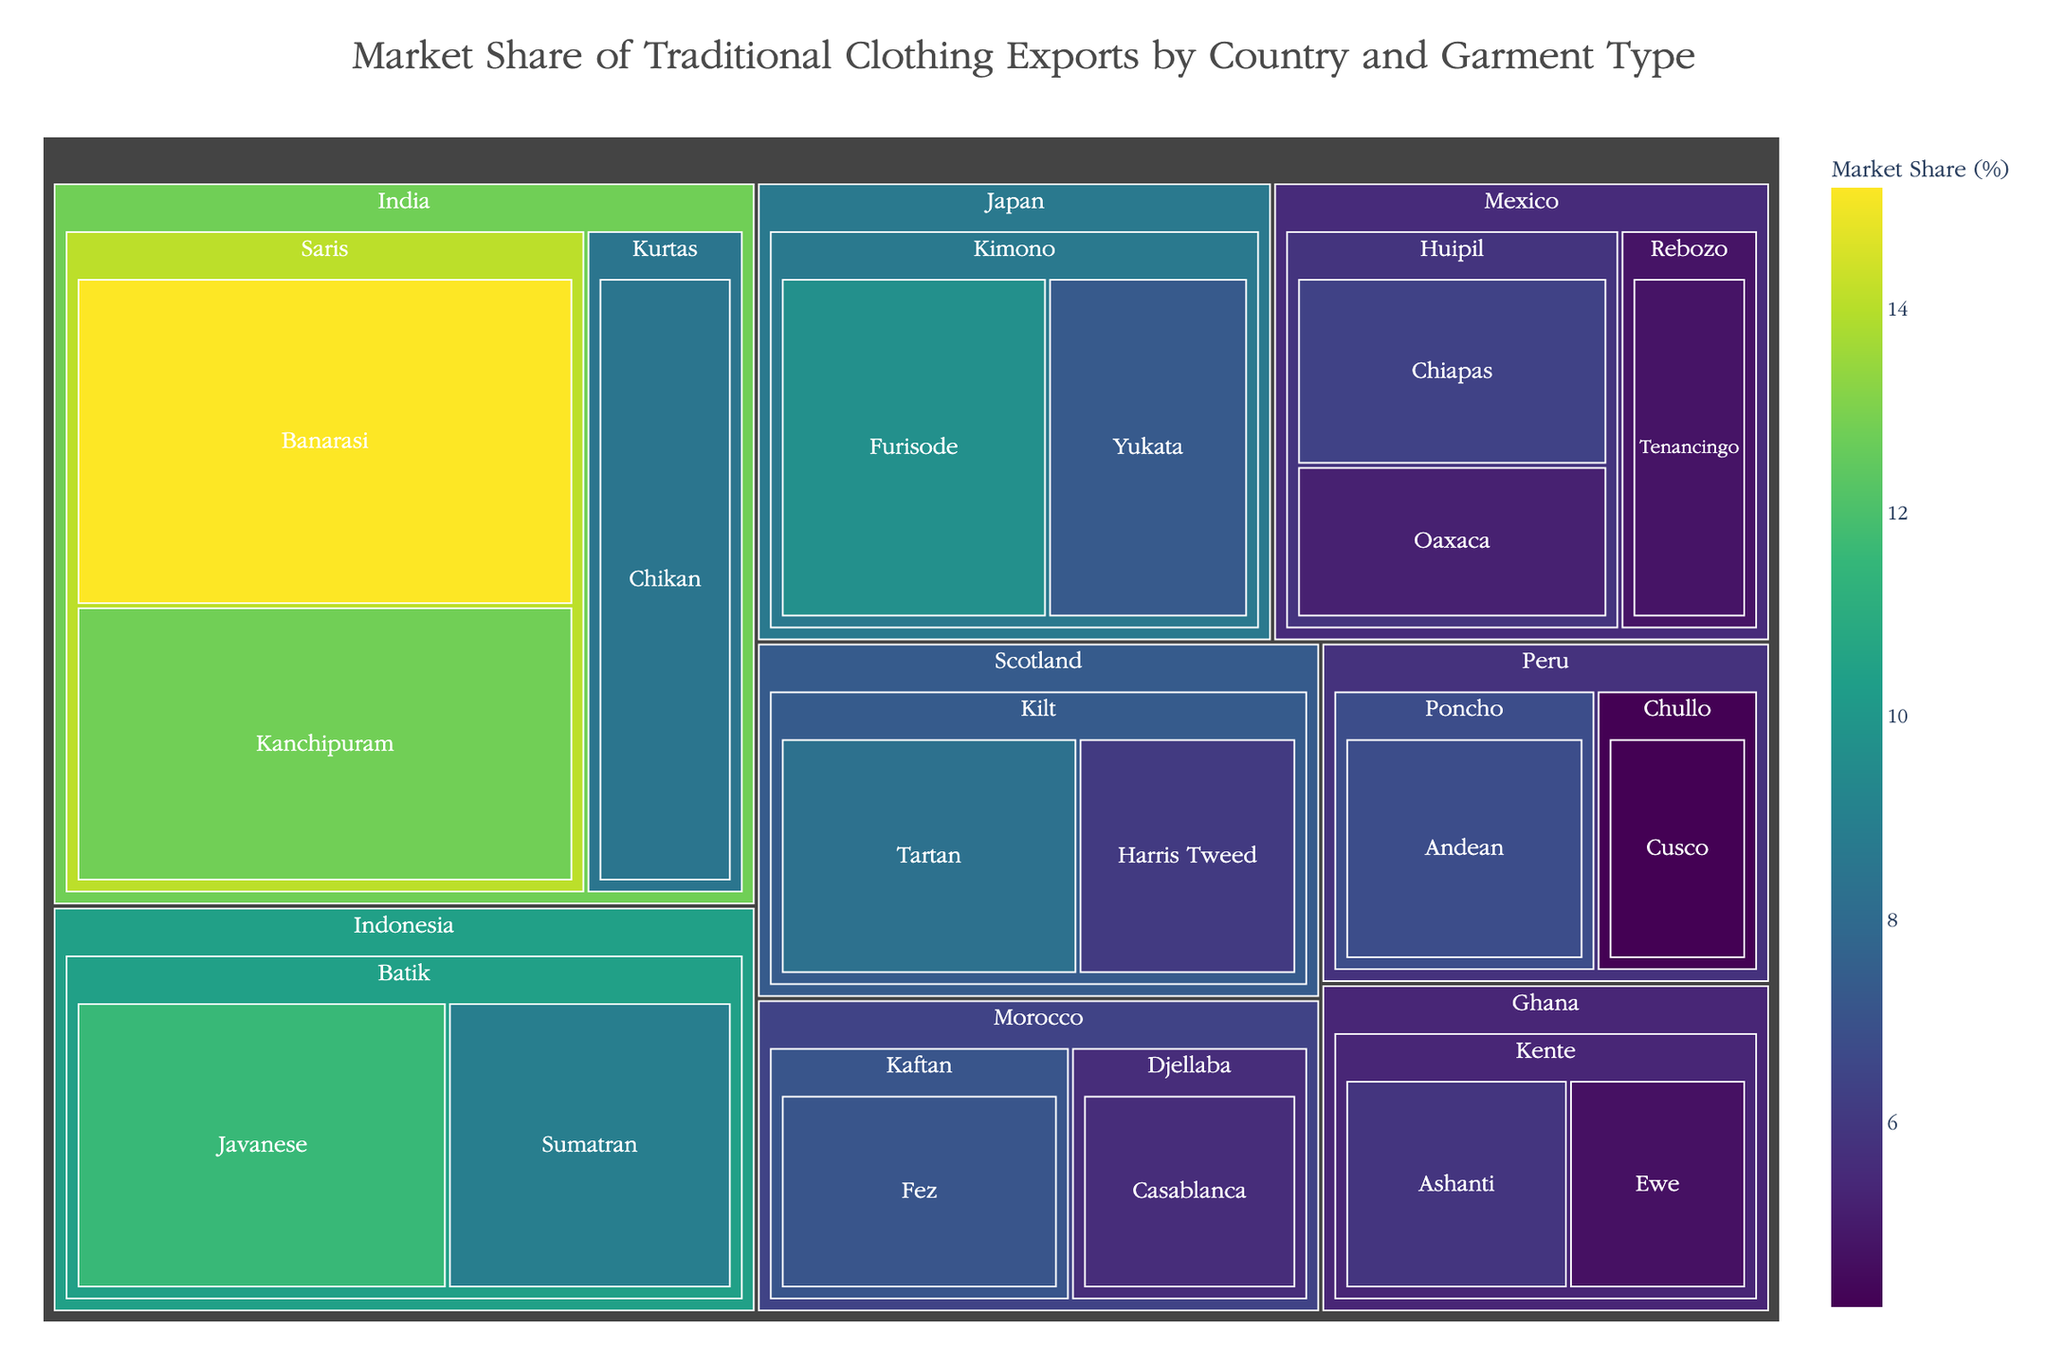How many total garment types does India export according to the treemap? To find the total number of garment types India exports, count each unique subcategory (Banarasi, Kanchipuram, Chikan) under the categories listed for India (Saris, Kurtas).
Answer: 3 Which countries export Kente textiles, and what are the respective market shares of these textiles? Locate the country label "Ghana" and identify the subcategories under Kente (Ashanti, Ewe). Look at the market share values next to each subcategory. Ghana exports Kente textiles with Ashanti having a market share of 5.9% and Ewe having a market share of 4.7%.
Answer: Ghana: Ashanti 5.9%, Ewe 4.7% What is the combined market share of traditional clothing exports for Mexico? Add the market share values for each subcategory under Mexico (Chiapas 6.4%, Oaxaca 5.2%, Tenancingo 4.8%). Combined market share = 6.4 + 5.2 + 4.8 = 16.4%.
Answer: 16.4% Which garment type has the highest market share in the treemap? Identify the highest value in the treemap, which represents the market share of each subcategory. Banarasi saris from India have the highest market share at 15.2%.
Answer: Banarasi saris Compare the market share of Furisode Kimono from Japan to Chikan Kurtas from India. Locate the market share values for Furisode Kimono (9.7%) and Chikan Kurtas (8.5%). Compare the two values. Furisode has a higher market share than Chikan Kurtas.
Answer: Furisode Kimono has a higher market share (9.7% vs. 8.5%) What is the total market share for Kimono exports from Japan? Add the market share values for all subcategories under Kimono (Furisode 9.7%, Yukata 7.3%). Total market share = 9.7 + 7.3 = 17%.
Answer: 17% How many countries export Saris according to the treemap? Identify the countries listed under the category "Saris". Only India is listed under the Saris category.
Answer: 1 (India) What is the market share difference between the Ashanti and Ewe subcategories of Kente textiles from Ghana? Identify the market share of Ashanti (5.9%) and Ewe (4.7%). Subtract the smaller value from the larger one: 5.9 - 4.7 = 1.2.
Answer: 1.2% What is the market share of Indonesian Batik compared to Moroccan Kaftan? Calculate the total market share of Batik (Javanese 11.6% + Sumatran 8.9% = 20.5%) and compare it to the market share of Kaftan (7.1%). Indonesian Batik has a higher market share.
Answer: Indonesian Batik 20.5% vs. Moroccan Kaftan 7.1% Which country has the lowest market share for any single subcategory, and what is that value? Identify the subcategory with the lowest market share value in the treemap. Chullo from Peru has the lowest market share at 4.2%.
Answer: Peru, Chullo (4.2%) 